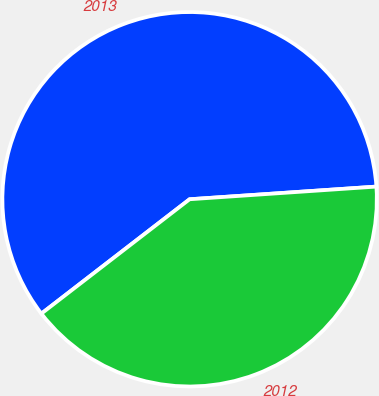Convert chart. <chart><loc_0><loc_0><loc_500><loc_500><pie_chart><fcel>2013<fcel>2012<nl><fcel>59.38%<fcel>40.62%<nl></chart> 